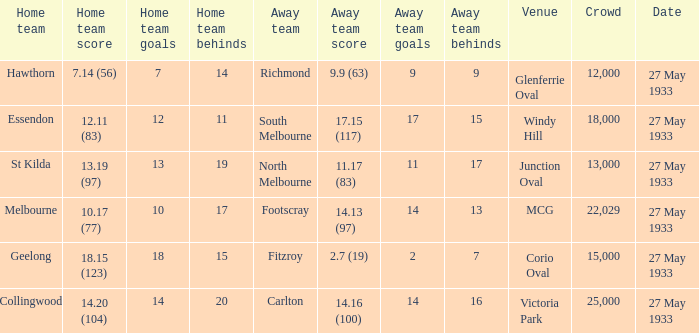During st kilda's home game, what was the number of people in the crowd? 13000.0. 